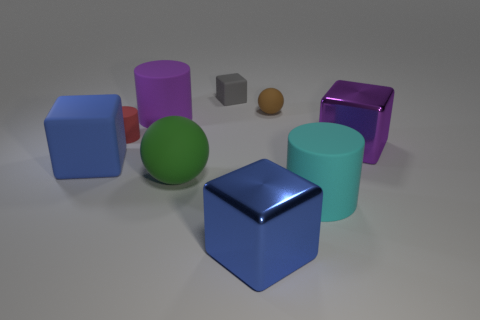Could you describe the lighting source in the image? The lighting in the image appears to be diffused overhead illumination, casting soft shadows directly beneath the objects, indicating the light source might be positioned above them, possibly out of the frame. 